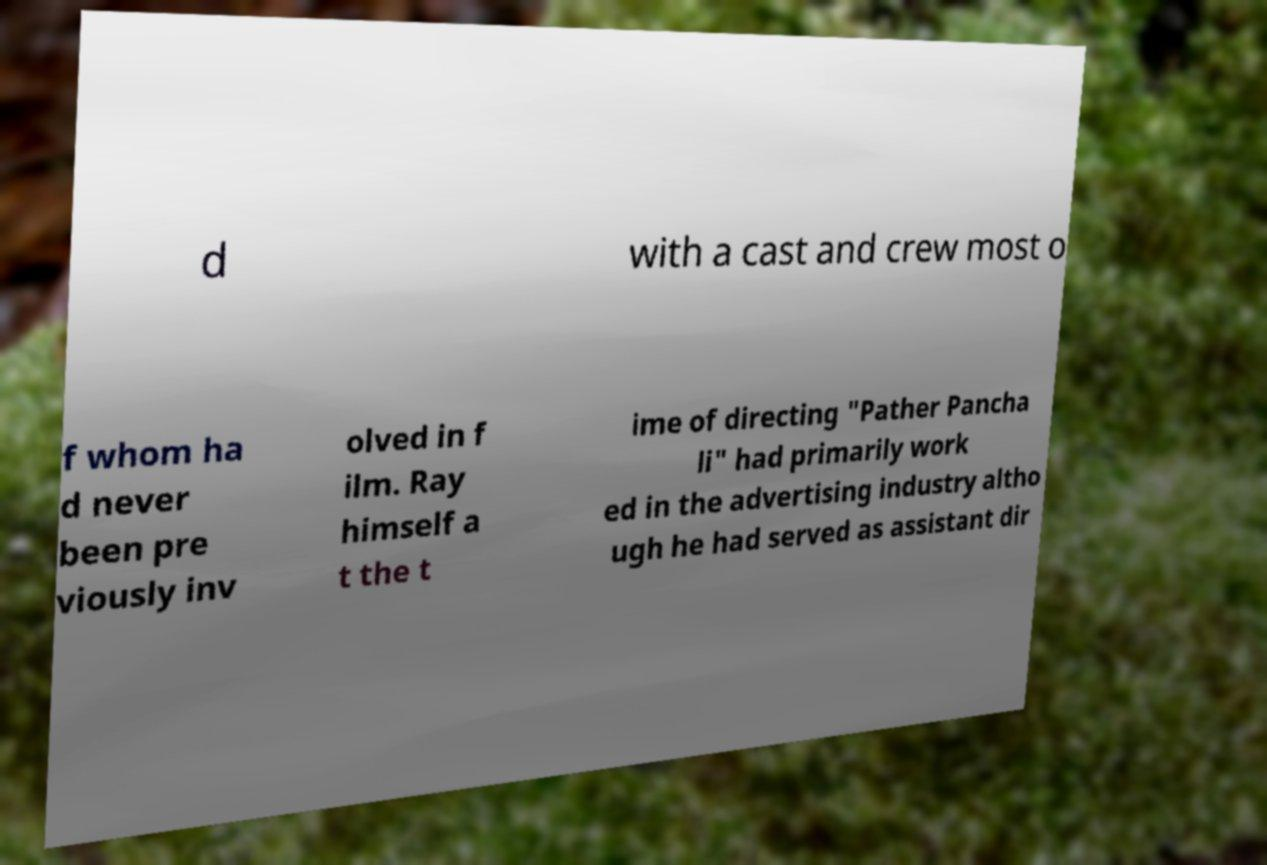Could you assist in decoding the text presented in this image and type it out clearly? d with a cast and crew most o f whom ha d never been pre viously inv olved in f ilm. Ray himself a t the t ime of directing "Pather Pancha li" had primarily work ed in the advertising industry altho ugh he had served as assistant dir 